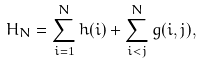<formula> <loc_0><loc_0><loc_500><loc_500>H _ { N } = \sum _ { i = 1 } ^ { N } h ( i ) + \sum _ { i < j } ^ { N } g ( i , j ) ,</formula> 